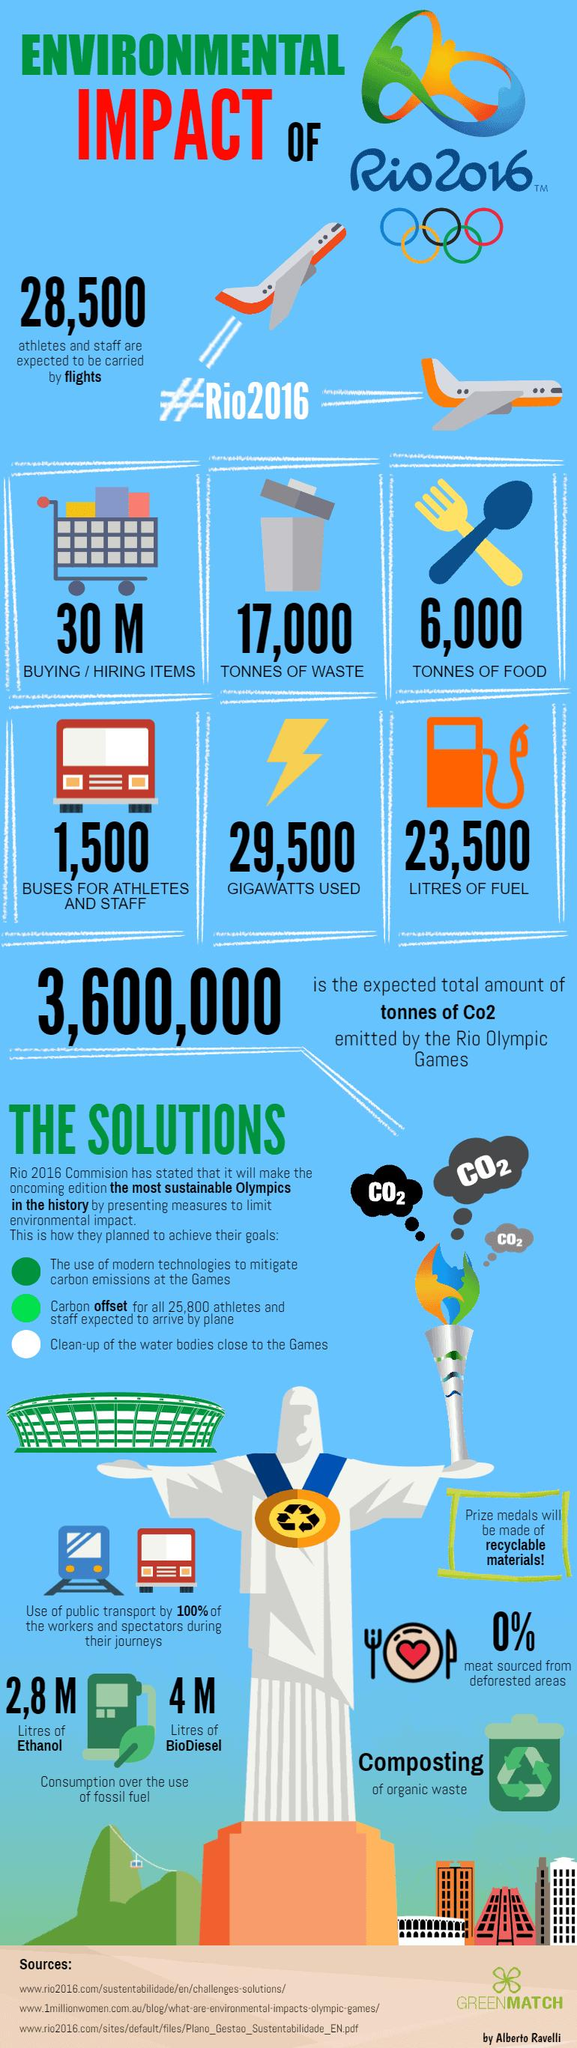List a handful of essential elements in this visual. The amount of waste generated during the Olympic Games 2016 was estimated to be approximately 17,000 metric tons. 